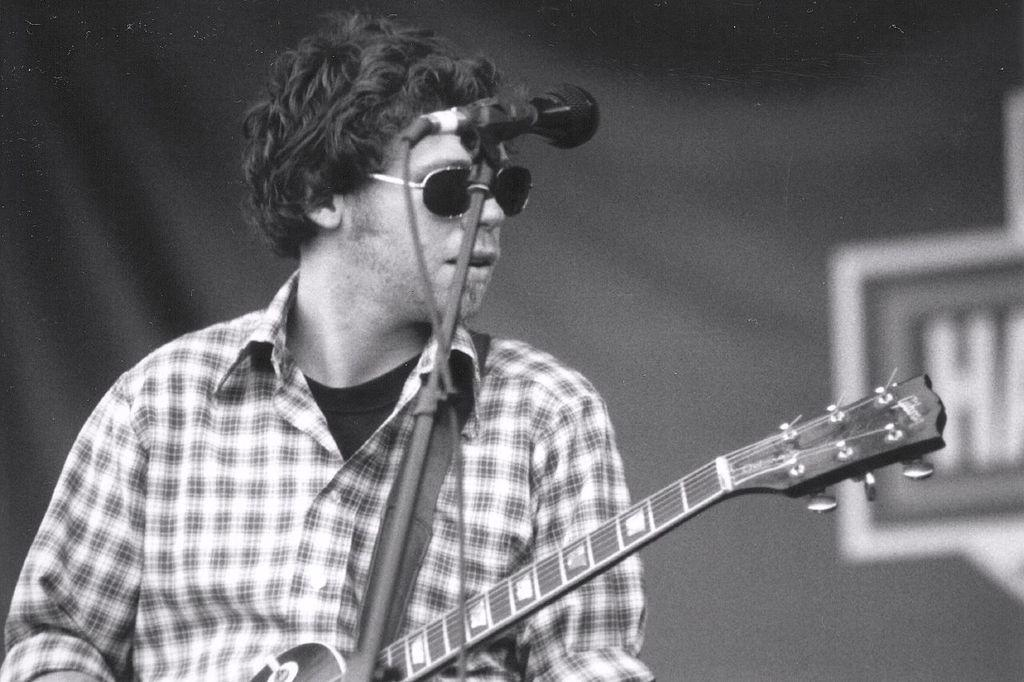What is the man in the image holding? The man is holding a guitar. What object is present in the image that is commonly used for amplifying sound? There is a microphone (mic) in the image. Where is the faucet located in the image? There is no faucet present in the image. What direction is the man facing in the image? The direction the man is facing cannot be determined from the image alone. 